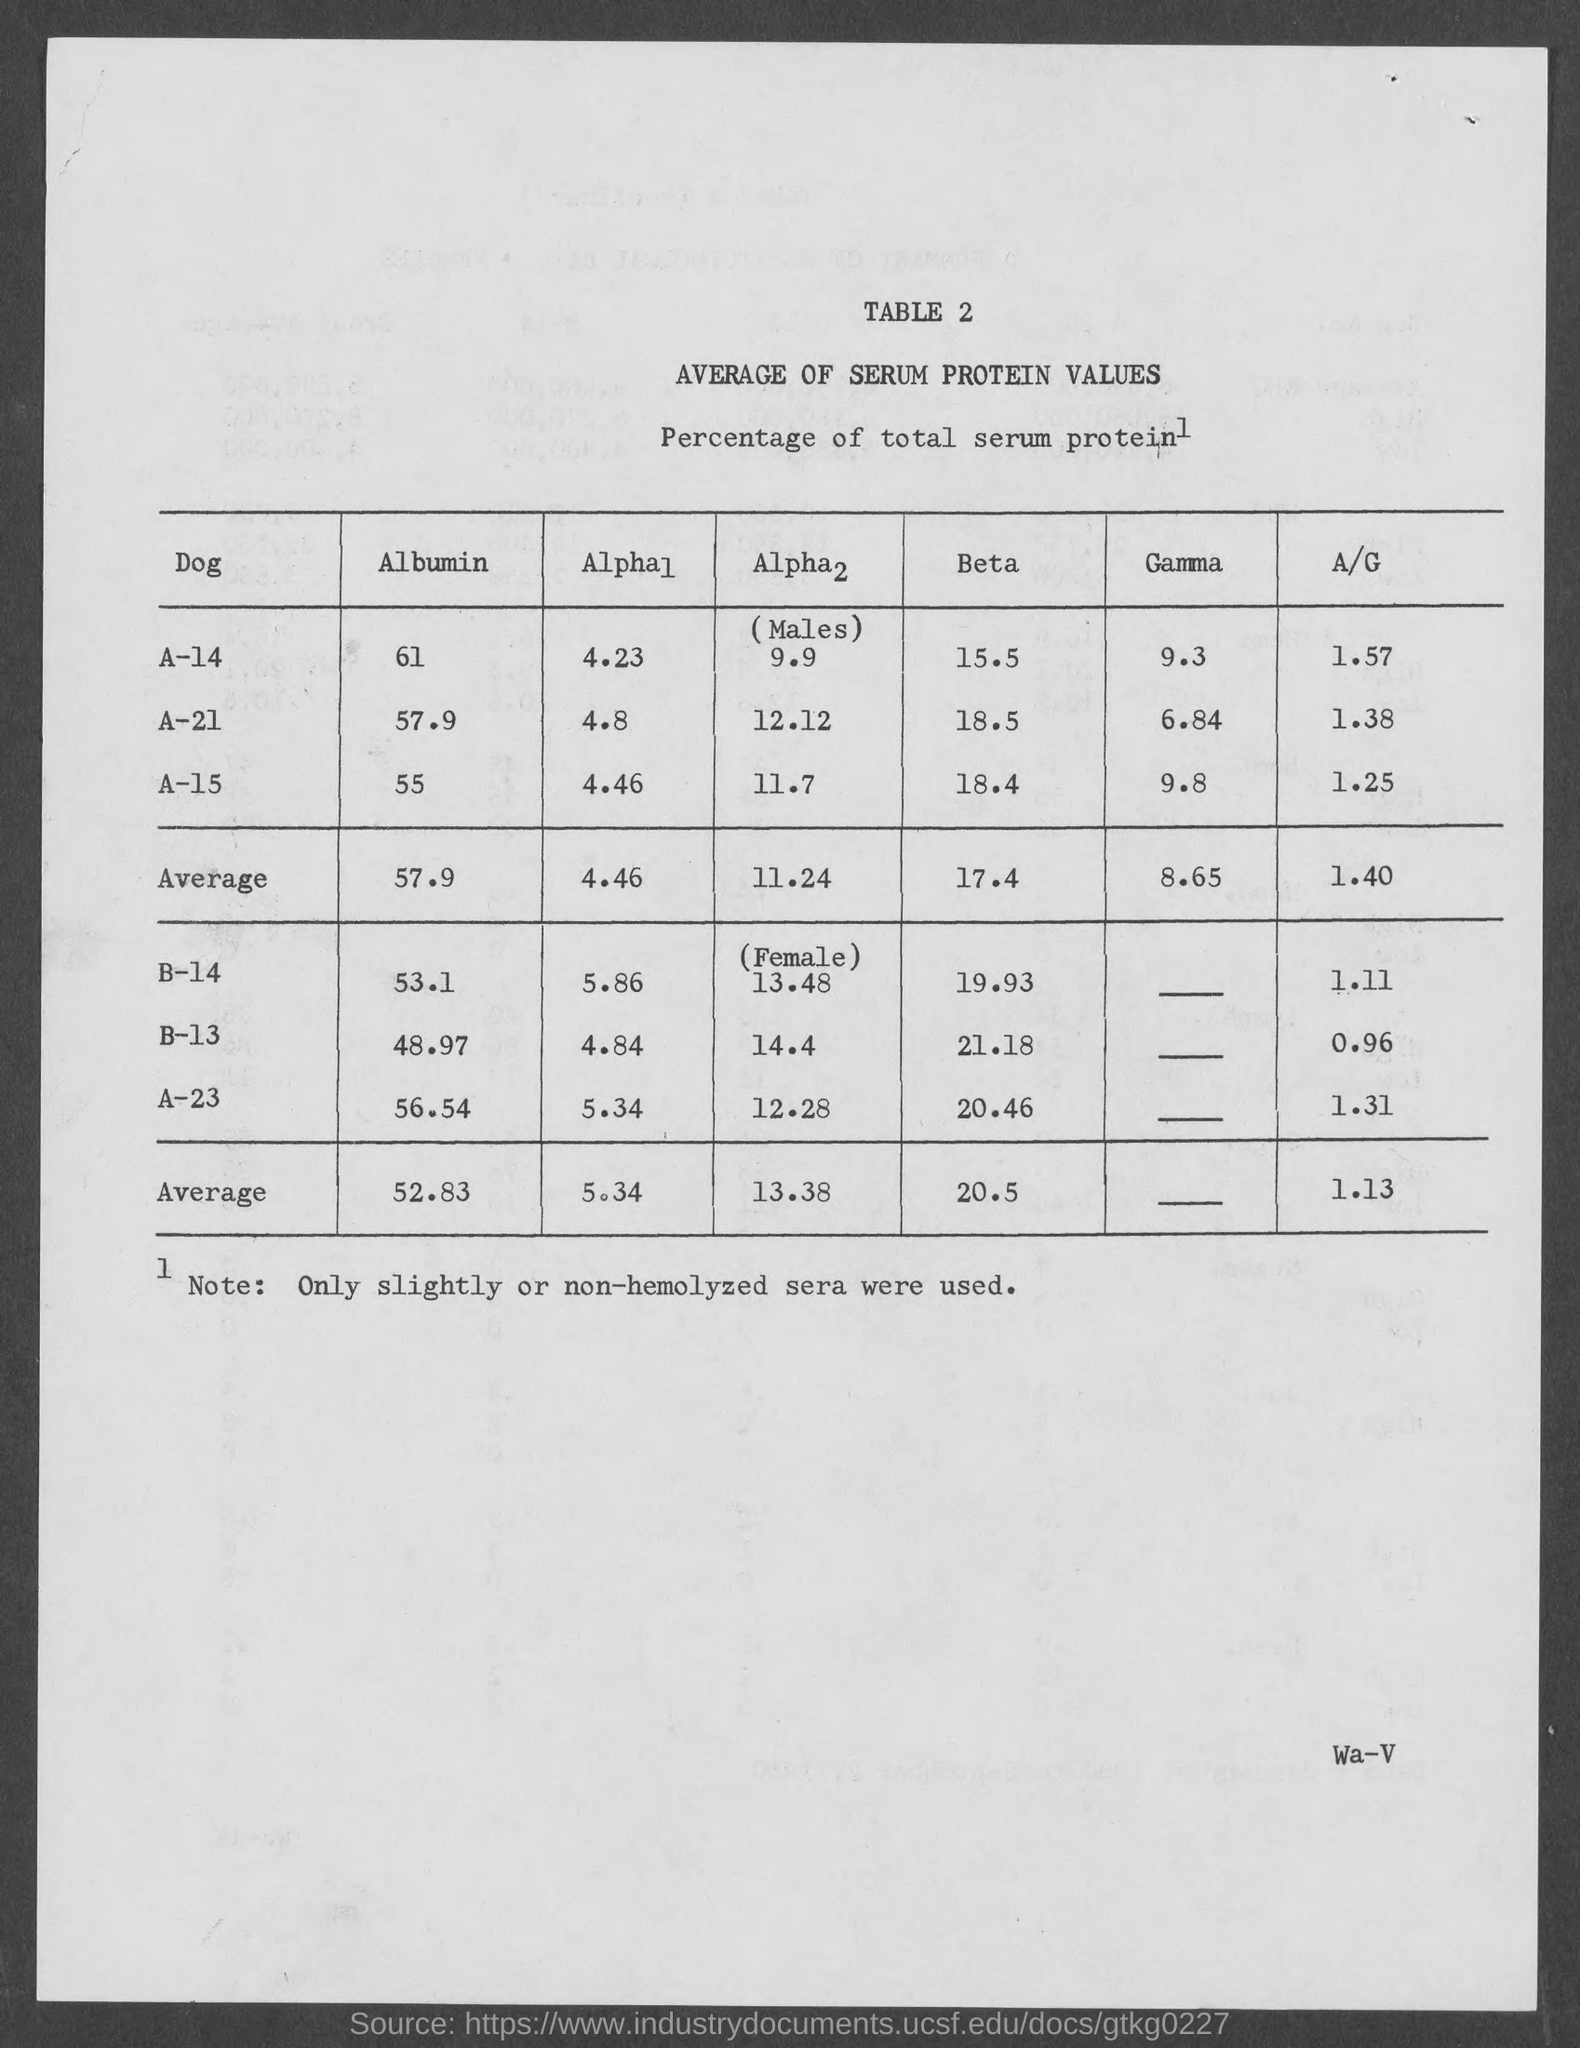Mention a couple of crucial points in this snapshot. The title of Table 2 is 'Average of Serum Protein Values.' 